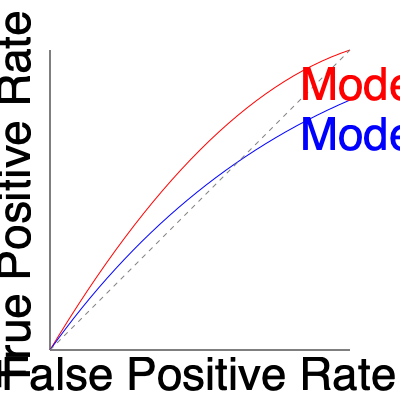Given the ROC curves for two machine learning models (A and B) shown in the graph, which model demonstrates better overall performance, and why? To compare the performance of two machine learning models using ROC curves, we need to consider the following steps:

1. Understand ROC curves:
   - The x-axis represents the False Positive Rate (FPR)
   - The y-axis represents the True Positive Rate (TPR)
   - A perfect classifier would have a point at (0,1)

2. Compare the curves:
   - Model A (red curve) is generally higher than Model B (blue curve)
   - This means Model A has a higher TPR for most FPR values

3. Consider the Area Under the Curve (AUC):
   - The AUC is a single metric summarizing the ROC curve
   - A larger AUC indicates better overall performance
   - Visually, Model A has a larger area under its curve compared to Model B

4. Analyze specific regions:
   - Model A performs better in most regions of the graph
   - It achieves higher TPR values for the same FPR values

5. Consider the application context:
   - Without specific requirements, we generally prefer the model with the larger AUC

Given these considerations, Model A demonstrates better overall performance because it has a higher ROC curve and a larger AUC, indicating superior discrimination ability across various classification thresholds.
Answer: Model A, due to higher ROC curve and larger AUC. 